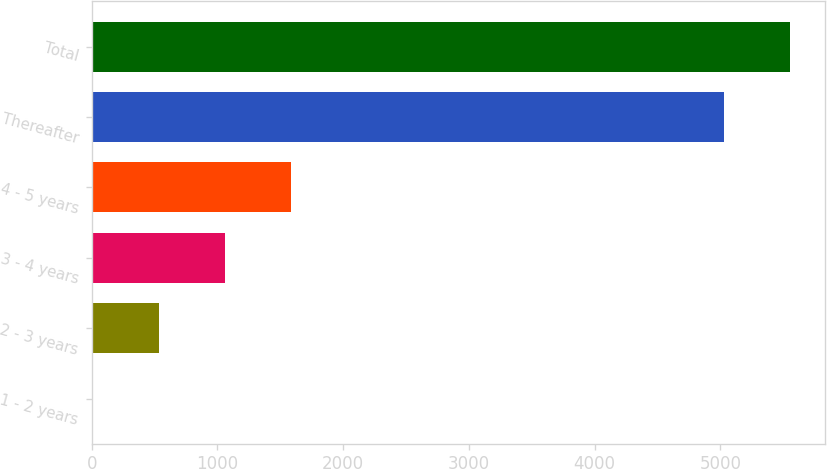Convert chart to OTSL. <chart><loc_0><loc_0><loc_500><loc_500><bar_chart><fcel>1 - 2 years<fcel>2 - 3 years<fcel>3 - 4 years<fcel>4 - 5 years<fcel>Thereafter<fcel>Total<nl><fcel>9<fcel>535.7<fcel>1062.4<fcel>1589.1<fcel>5030<fcel>5556.7<nl></chart> 